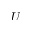<formula> <loc_0><loc_0><loc_500><loc_500>U</formula> 